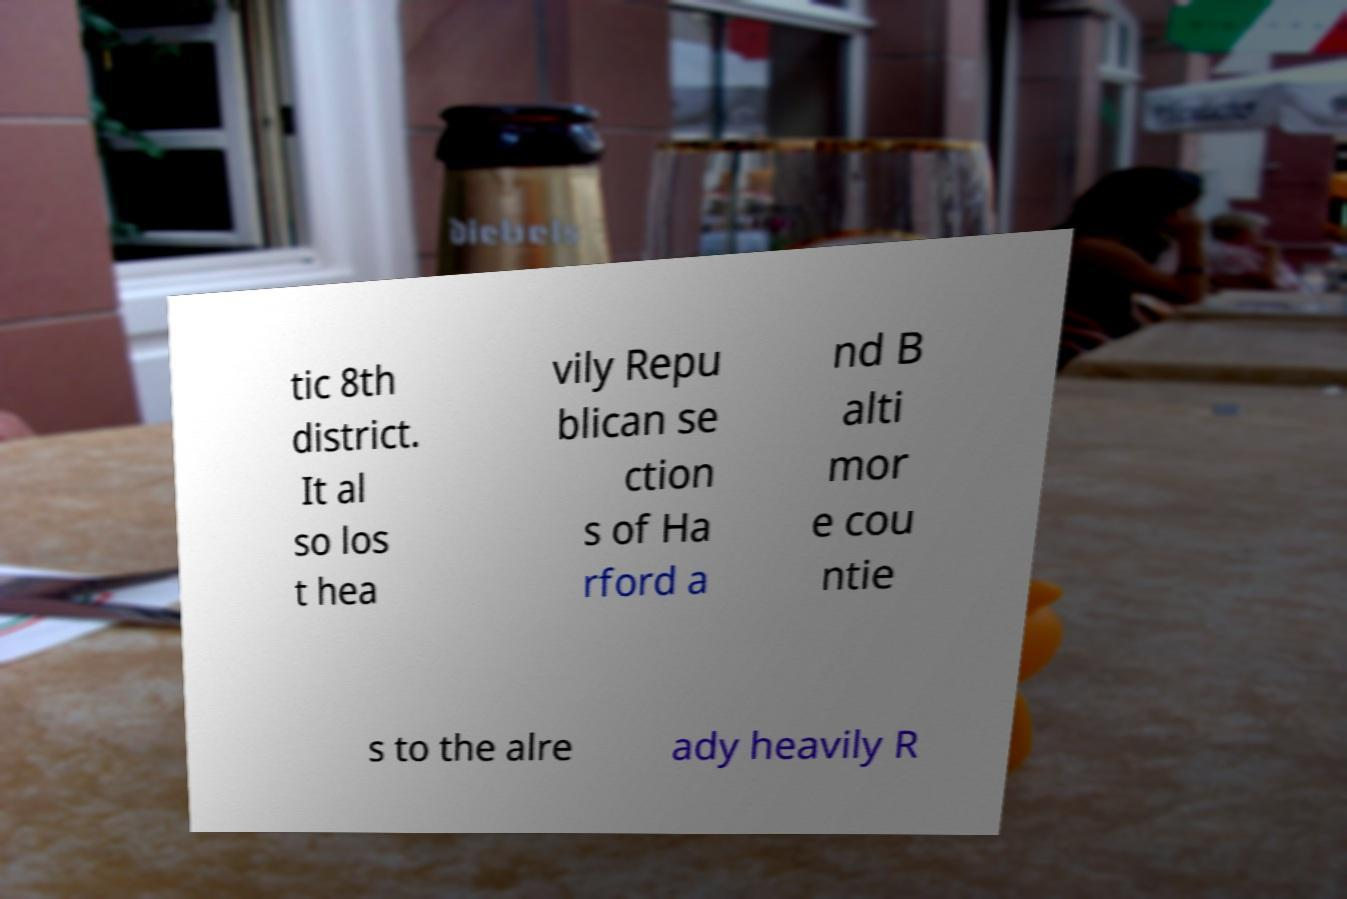Can you read and provide the text displayed in the image?This photo seems to have some interesting text. Can you extract and type it out for me? tic 8th district. It al so los t hea vily Repu blican se ction s of Ha rford a nd B alti mor e cou ntie s to the alre ady heavily R 